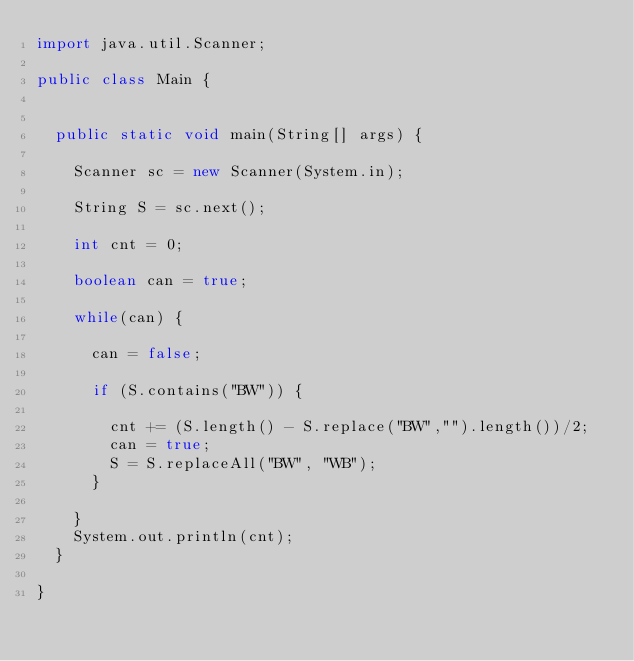Convert code to text. <code><loc_0><loc_0><loc_500><loc_500><_Java_>import java.util.Scanner;

public class Main {


	public static void main(String[] args) {

		Scanner sc = new Scanner(System.in);

		String S = sc.next();

		int cnt = 0;

		boolean can = true;

		while(can) {

			can = false;

			if (S.contains("BW")) {

				cnt += (S.length() - S.replace("BW","").length())/2;
				can = true;
				S = S.replaceAll("BW", "WB");
			}

		}
		System.out.println(cnt);
	}

}
</code> 